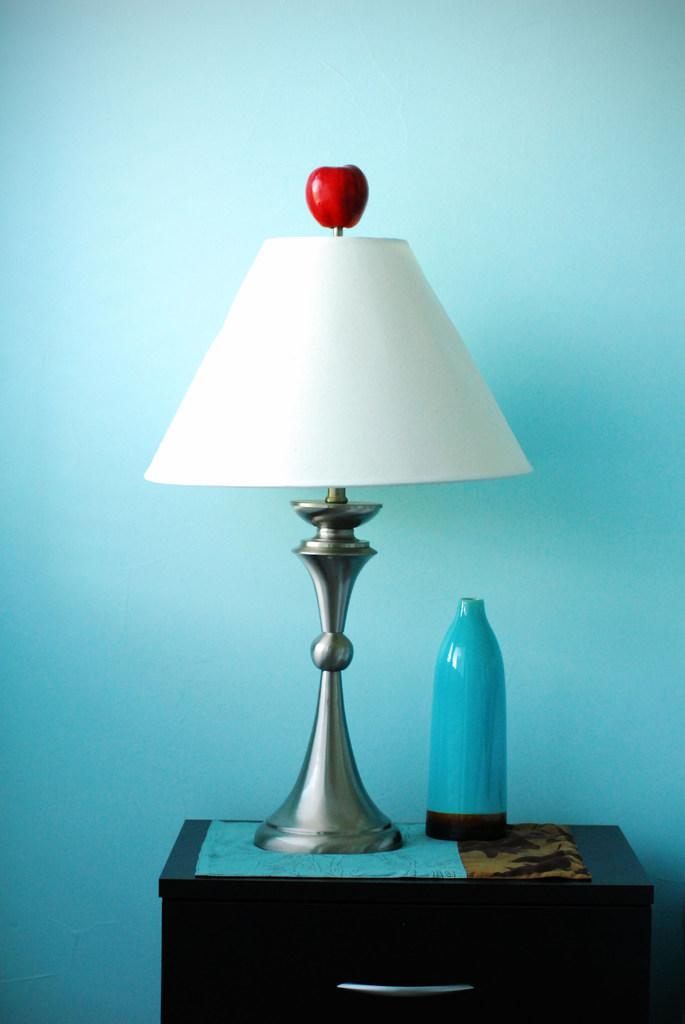What piece of furniture is present in the image? There is a table in the image. What object is placed on the table? A lamp and a bottle are placed on the table. Is there anything unusual about the lamp? Yes, there is an apple on the lamp. What can be seen in the background of the image? There is a wall in the background of the image. How many screws can be seen holding the lamp to the table in the image? There is no mention of screws in the image, and the lamp is not attached to the table. Can you tell me how many cherries are on the apple on the lamp in the image? There is no mention of cherries in the image; the apple is the only fruit visible. 